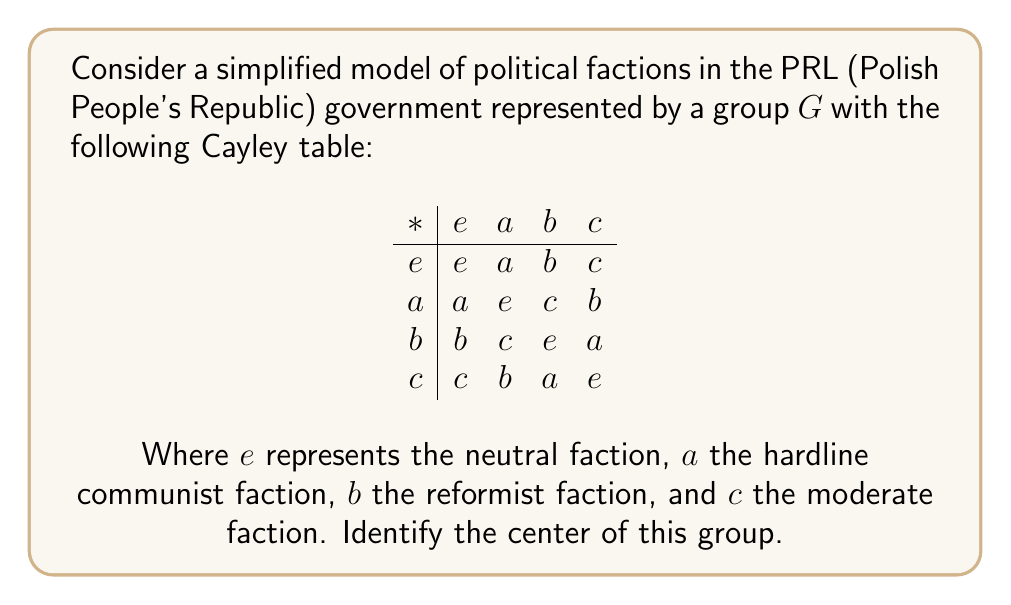Give your solution to this math problem. To find the center of the group, we need to identify all elements that commute with every other element in the group. An element $x$ is in the center if and only if $xy = yx$ for all $y$ in $G$.

Let's check each element:

1. For $e$:
   $e * y = y * e$ for all $y \in G$ (by definition of the identity element)

2. For $a$:
   $a * e = e * a = a$
   $a * a = a * a = e$
   $a * b = c \neq b = b * a$
   $a * c = b \neq c = c * a$
   $a$ does not commute with $b$ and $c$, so it's not in the center.

3. For $b$:
   $b * e = e * b = b$
   $b * a = c \neq a = a * b$
   $b * b = b * b = e$
   $b * c = a \neq c = c * b$
   $b$ does not commute with $a$ and $c$, so it's not in the center.

4. For $c$:
   $c * e = e * c = c$
   $c * a = b \neq a = a * c$
   $c * b = a \neq b = b * c$
   $c * c = c * c = e$
   $c$ does not commute with $a$ and $b$, so it's not in the center.

Therefore, only the identity element $e$ commutes with all other elements.
Answer: The center of the group is $\{e\}$, representing the neutral faction. 